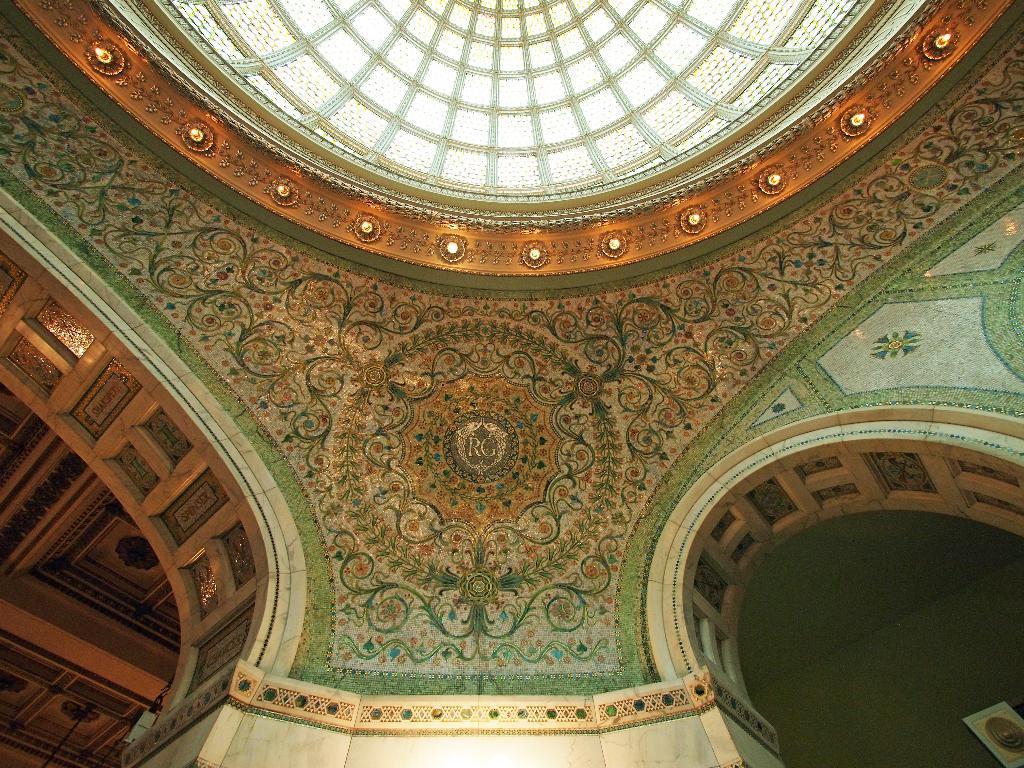Please provide a concise description of this image. In this image we can see walls with design and lights to the ceiling. 